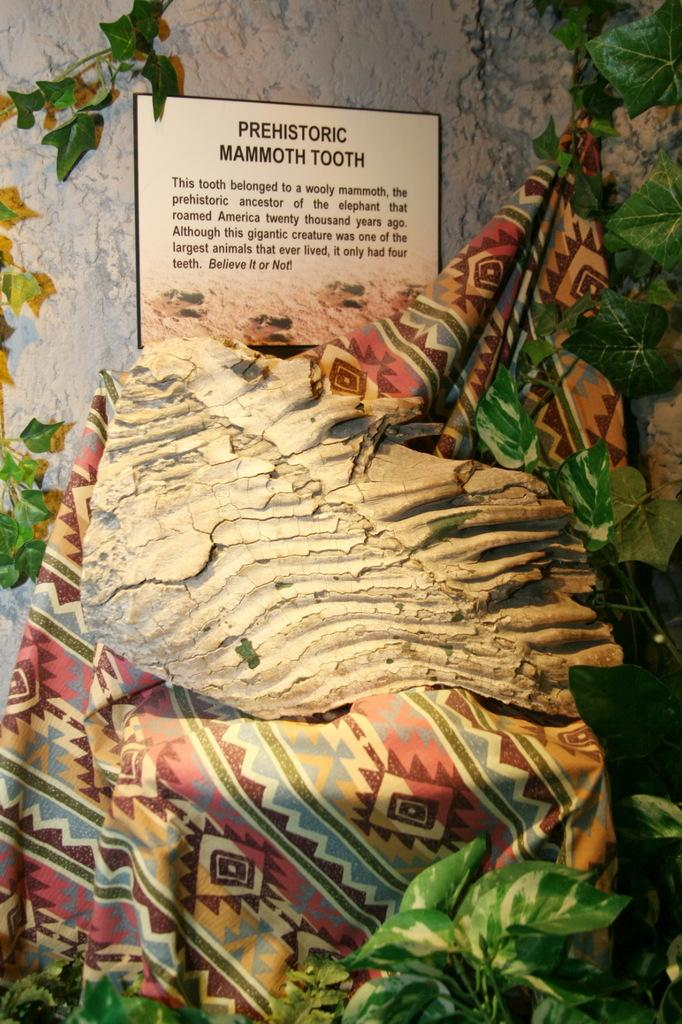<image>
Offer a succinct explanation of the picture presented. Sign inside an exhibit that says "Prehistoric Mammoth Tooth". 